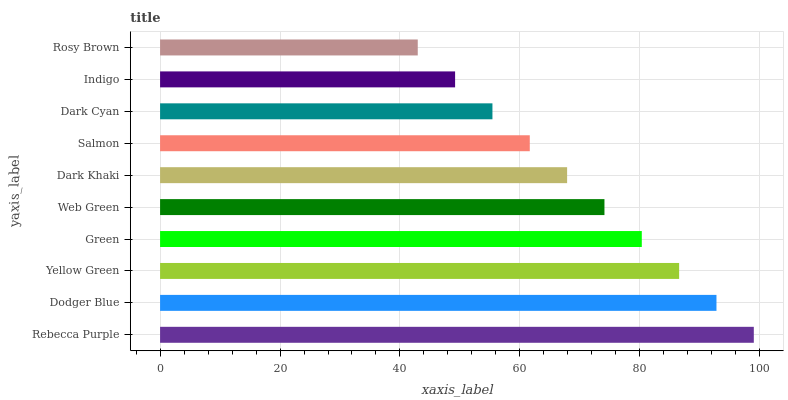Is Rosy Brown the minimum?
Answer yes or no. Yes. Is Rebecca Purple the maximum?
Answer yes or no. Yes. Is Dodger Blue the minimum?
Answer yes or no. No. Is Dodger Blue the maximum?
Answer yes or no. No. Is Rebecca Purple greater than Dodger Blue?
Answer yes or no. Yes. Is Dodger Blue less than Rebecca Purple?
Answer yes or no. Yes. Is Dodger Blue greater than Rebecca Purple?
Answer yes or no. No. Is Rebecca Purple less than Dodger Blue?
Answer yes or no. No. Is Web Green the high median?
Answer yes or no. Yes. Is Dark Khaki the low median?
Answer yes or no. Yes. Is Rebecca Purple the high median?
Answer yes or no. No. Is Web Green the low median?
Answer yes or no. No. 